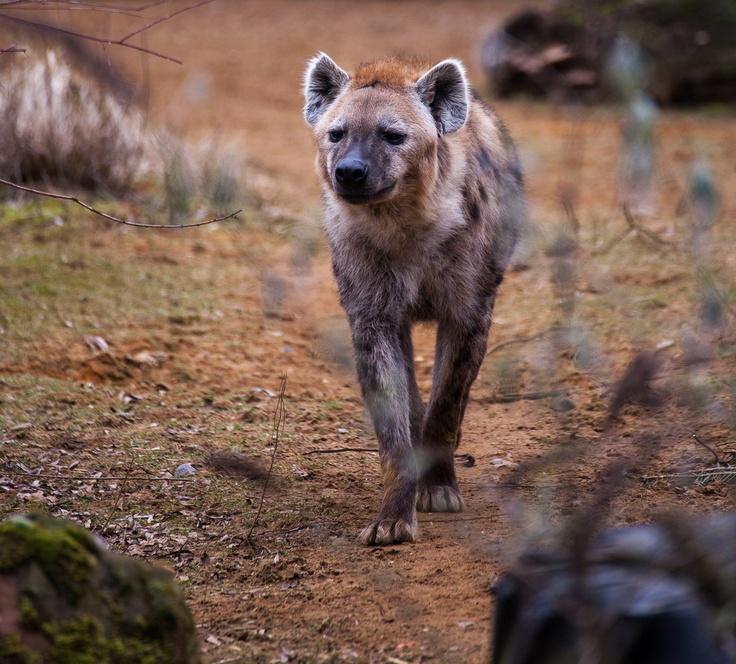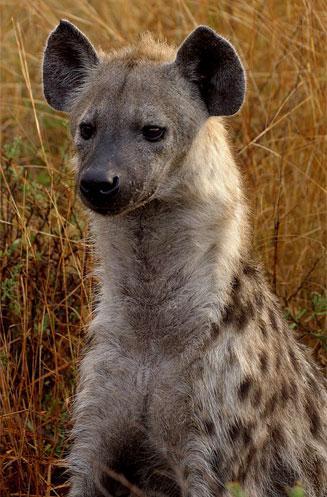The first image is the image on the left, the second image is the image on the right. Analyze the images presented: Is the assertion "The animal in the image on the left is facing the camera" valid? Answer yes or no. Yes. 